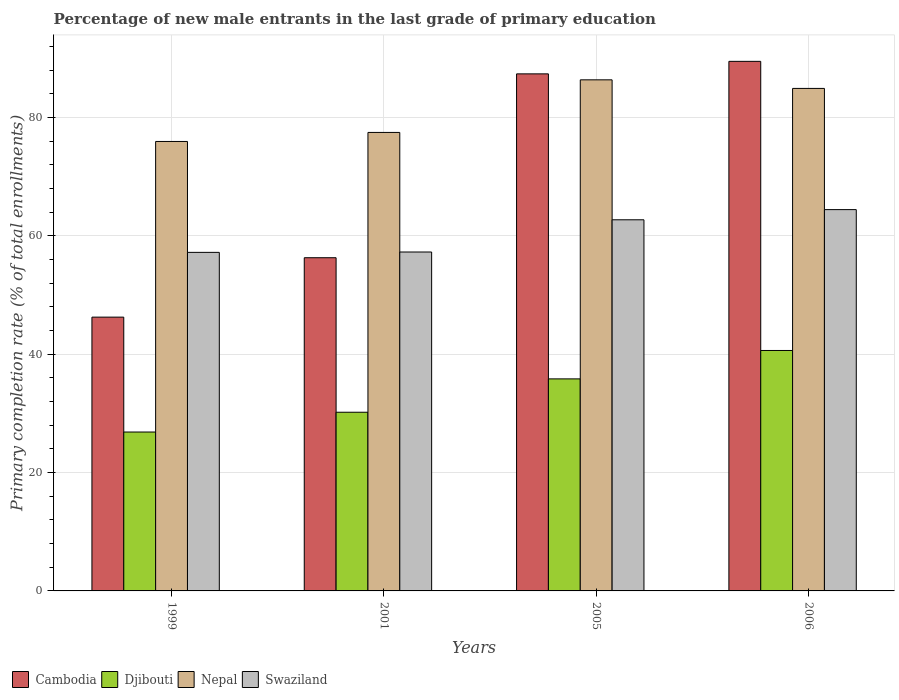Are the number of bars per tick equal to the number of legend labels?
Your response must be concise. Yes. Are the number of bars on each tick of the X-axis equal?
Your answer should be very brief. Yes. How many bars are there on the 3rd tick from the left?
Keep it short and to the point. 4. How many bars are there on the 4th tick from the right?
Keep it short and to the point. 4. What is the percentage of new male entrants in Nepal in 2005?
Keep it short and to the point. 86.36. Across all years, what is the maximum percentage of new male entrants in Cambodia?
Give a very brief answer. 89.49. Across all years, what is the minimum percentage of new male entrants in Swaziland?
Provide a succinct answer. 57.21. What is the total percentage of new male entrants in Swaziland in the graph?
Give a very brief answer. 241.63. What is the difference between the percentage of new male entrants in Swaziland in 2001 and that in 2006?
Your answer should be very brief. -7.16. What is the difference between the percentage of new male entrants in Swaziland in 2005 and the percentage of new male entrants in Nepal in 2006?
Your response must be concise. -22.2. What is the average percentage of new male entrants in Nepal per year?
Your answer should be compact. 81.18. In the year 2006, what is the difference between the percentage of new male entrants in Swaziland and percentage of new male entrants in Cambodia?
Your answer should be very brief. -25.05. What is the ratio of the percentage of new male entrants in Nepal in 2001 to that in 2005?
Your answer should be compact. 0.9. Is the percentage of new male entrants in Swaziland in 2001 less than that in 2005?
Provide a succinct answer. Yes. Is the difference between the percentage of new male entrants in Swaziland in 1999 and 2001 greater than the difference between the percentage of new male entrants in Cambodia in 1999 and 2001?
Give a very brief answer. Yes. What is the difference between the highest and the second highest percentage of new male entrants in Cambodia?
Ensure brevity in your answer.  2.12. What is the difference between the highest and the lowest percentage of new male entrants in Djibouti?
Ensure brevity in your answer.  13.78. Is the sum of the percentage of new male entrants in Djibouti in 2001 and 2005 greater than the maximum percentage of new male entrants in Swaziland across all years?
Offer a very short reply. Yes. What does the 4th bar from the left in 2001 represents?
Provide a short and direct response. Swaziland. What does the 3rd bar from the right in 2006 represents?
Your answer should be very brief. Djibouti. How many bars are there?
Provide a succinct answer. 16. Does the graph contain any zero values?
Offer a terse response. No. What is the title of the graph?
Provide a short and direct response. Percentage of new male entrants in the last grade of primary education. Does "San Marino" appear as one of the legend labels in the graph?
Your response must be concise. No. What is the label or title of the Y-axis?
Offer a terse response. Primary completion rate (% of total enrollments). What is the Primary completion rate (% of total enrollments) in Cambodia in 1999?
Offer a very short reply. 46.26. What is the Primary completion rate (% of total enrollments) of Djibouti in 1999?
Make the answer very short. 26.85. What is the Primary completion rate (% of total enrollments) in Nepal in 1999?
Offer a terse response. 75.95. What is the Primary completion rate (% of total enrollments) in Swaziland in 1999?
Offer a terse response. 57.21. What is the Primary completion rate (% of total enrollments) of Cambodia in 2001?
Give a very brief answer. 56.3. What is the Primary completion rate (% of total enrollments) in Djibouti in 2001?
Your answer should be compact. 30.19. What is the Primary completion rate (% of total enrollments) of Nepal in 2001?
Provide a short and direct response. 77.48. What is the Primary completion rate (% of total enrollments) of Swaziland in 2001?
Provide a short and direct response. 57.27. What is the Primary completion rate (% of total enrollments) in Cambodia in 2005?
Give a very brief answer. 87.37. What is the Primary completion rate (% of total enrollments) of Djibouti in 2005?
Offer a terse response. 35.83. What is the Primary completion rate (% of total enrollments) in Nepal in 2005?
Offer a very short reply. 86.36. What is the Primary completion rate (% of total enrollments) in Swaziland in 2005?
Offer a very short reply. 62.72. What is the Primary completion rate (% of total enrollments) in Cambodia in 2006?
Your answer should be compact. 89.49. What is the Primary completion rate (% of total enrollments) in Djibouti in 2006?
Ensure brevity in your answer.  40.63. What is the Primary completion rate (% of total enrollments) in Nepal in 2006?
Your answer should be very brief. 84.91. What is the Primary completion rate (% of total enrollments) in Swaziland in 2006?
Your response must be concise. 64.43. Across all years, what is the maximum Primary completion rate (% of total enrollments) of Cambodia?
Make the answer very short. 89.49. Across all years, what is the maximum Primary completion rate (% of total enrollments) of Djibouti?
Your answer should be compact. 40.63. Across all years, what is the maximum Primary completion rate (% of total enrollments) of Nepal?
Provide a short and direct response. 86.36. Across all years, what is the maximum Primary completion rate (% of total enrollments) of Swaziland?
Make the answer very short. 64.43. Across all years, what is the minimum Primary completion rate (% of total enrollments) in Cambodia?
Give a very brief answer. 46.26. Across all years, what is the minimum Primary completion rate (% of total enrollments) in Djibouti?
Offer a very short reply. 26.85. Across all years, what is the minimum Primary completion rate (% of total enrollments) in Nepal?
Make the answer very short. 75.95. Across all years, what is the minimum Primary completion rate (% of total enrollments) in Swaziland?
Offer a very short reply. 57.21. What is the total Primary completion rate (% of total enrollments) of Cambodia in the graph?
Your answer should be compact. 279.43. What is the total Primary completion rate (% of total enrollments) of Djibouti in the graph?
Your answer should be compact. 133.5. What is the total Primary completion rate (% of total enrollments) in Nepal in the graph?
Make the answer very short. 324.71. What is the total Primary completion rate (% of total enrollments) in Swaziland in the graph?
Your answer should be very brief. 241.63. What is the difference between the Primary completion rate (% of total enrollments) in Cambodia in 1999 and that in 2001?
Make the answer very short. -10.04. What is the difference between the Primary completion rate (% of total enrollments) of Djibouti in 1999 and that in 2001?
Provide a succinct answer. -3.34. What is the difference between the Primary completion rate (% of total enrollments) of Nepal in 1999 and that in 2001?
Make the answer very short. -1.53. What is the difference between the Primary completion rate (% of total enrollments) of Swaziland in 1999 and that in 2001?
Keep it short and to the point. -0.06. What is the difference between the Primary completion rate (% of total enrollments) of Cambodia in 1999 and that in 2005?
Make the answer very short. -41.11. What is the difference between the Primary completion rate (% of total enrollments) of Djibouti in 1999 and that in 2005?
Make the answer very short. -8.98. What is the difference between the Primary completion rate (% of total enrollments) in Nepal in 1999 and that in 2005?
Give a very brief answer. -10.41. What is the difference between the Primary completion rate (% of total enrollments) of Swaziland in 1999 and that in 2005?
Offer a terse response. -5.5. What is the difference between the Primary completion rate (% of total enrollments) in Cambodia in 1999 and that in 2006?
Your response must be concise. -43.22. What is the difference between the Primary completion rate (% of total enrollments) in Djibouti in 1999 and that in 2006?
Ensure brevity in your answer.  -13.78. What is the difference between the Primary completion rate (% of total enrollments) in Nepal in 1999 and that in 2006?
Your response must be concise. -8.96. What is the difference between the Primary completion rate (% of total enrollments) in Swaziland in 1999 and that in 2006?
Your answer should be compact. -7.22. What is the difference between the Primary completion rate (% of total enrollments) of Cambodia in 2001 and that in 2005?
Offer a terse response. -31.07. What is the difference between the Primary completion rate (% of total enrollments) in Djibouti in 2001 and that in 2005?
Provide a short and direct response. -5.64. What is the difference between the Primary completion rate (% of total enrollments) of Nepal in 2001 and that in 2005?
Give a very brief answer. -8.89. What is the difference between the Primary completion rate (% of total enrollments) in Swaziland in 2001 and that in 2005?
Keep it short and to the point. -5.45. What is the difference between the Primary completion rate (% of total enrollments) of Cambodia in 2001 and that in 2006?
Your answer should be very brief. -33.18. What is the difference between the Primary completion rate (% of total enrollments) in Djibouti in 2001 and that in 2006?
Make the answer very short. -10.44. What is the difference between the Primary completion rate (% of total enrollments) in Nepal in 2001 and that in 2006?
Make the answer very short. -7.44. What is the difference between the Primary completion rate (% of total enrollments) of Swaziland in 2001 and that in 2006?
Offer a very short reply. -7.16. What is the difference between the Primary completion rate (% of total enrollments) of Cambodia in 2005 and that in 2006?
Provide a succinct answer. -2.12. What is the difference between the Primary completion rate (% of total enrollments) in Djibouti in 2005 and that in 2006?
Your response must be concise. -4.8. What is the difference between the Primary completion rate (% of total enrollments) of Nepal in 2005 and that in 2006?
Give a very brief answer. 1.45. What is the difference between the Primary completion rate (% of total enrollments) of Swaziland in 2005 and that in 2006?
Your answer should be very brief. -1.72. What is the difference between the Primary completion rate (% of total enrollments) in Cambodia in 1999 and the Primary completion rate (% of total enrollments) in Djibouti in 2001?
Give a very brief answer. 16.07. What is the difference between the Primary completion rate (% of total enrollments) in Cambodia in 1999 and the Primary completion rate (% of total enrollments) in Nepal in 2001?
Offer a very short reply. -31.21. What is the difference between the Primary completion rate (% of total enrollments) in Cambodia in 1999 and the Primary completion rate (% of total enrollments) in Swaziland in 2001?
Ensure brevity in your answer.  -11.01. What is the difference between the Primary completion rate (% of total enrollments) in Djibouti in 1999 and the Primary completion rate (% of total enrollments) in Nepal in 2001?
Offer a terse response. -50.63. What is the difference between the Primary completion rate (% of total enrollments) of Djibouti in 1999 and the Primary completion rate (% of total enrollments) of Swaziland in 2001?
Your response must be concise. -30.42. What is the difference between the Primary completion rate (% of total enrollments) in Nepal in 1999 and the Primary completion rate (% of total enrollments) in Swaziland in 2001?
Offer a very short reply. 18.68. What is the difference between the Primary completion rate (% of total enrollments) of Cambodia in 1999 and the Primary completion rate (% of total enrollments) of Djibouti in 2005?
Ensure brevity in your answer.  10.43. What is the difference between the Primary completion rate (% of total enrollments) in Cambodia in 1999 and the Primary completion rate (% of total enrollments) in Nepal in 2005?
Your response must be concise. -40.1. What is the difference between the Primary completion rate (% of total enrollments) of Cambodia in 1999 and the Primary completion rate (% of total enrollments) of Swaziland in 2005?
Provide a succinct answer. -16.45. What is the difference between the Primary completion rate (% of total enrollments) of Djibouti in 1999 and the Primary completion rate (% of total enrollments) of Nepal in 2005?
Your answer should be very brief. -59.51. What is the difference between the Primary completion rate (% of total enrollments) of Djibouti in 1999 and the Primary completion rate (% of total enrollments) of Swaziland in 2005?
Your answer should be very brief. -35.86. What is the difference between the Primary completion rate (% of total enrollments) in Nepal in 1999 and the Primary completion rate (% of total enrollments) in Swaziland in 2005?
Your answer should be very brief. 13.24. What is the difference between the Primary completion rate (% of total enrollments) in Cambodia in 1999 and the Primary completion rate (% of total enrollments) in Djibouti in 2006?
Ensure brevity in your answer.  5.63. What is the difference between the Primary completion rate (% of total enrollments) in Cambodia in 1999 and the Primary completion rate (% of total enrollments) in Nepal in 2006?
Give a very brief answer. -38.65. What is the difference between the Primary completion rate (% of total enrollments) of Cambodia in 1999 and the Primary completion rate (% of total enrollments) of Swaziland in 2006?
Provide a succinct answer. -18.17. What is the difference between the Primary completion rate (% of total enrollments) in Djibouti in 1999 and the Primary completion rate (% of total enrollments) in Nepal in 2006?
Your response must be concise. -58.06. What is the difference between the Primary completion rate (% of total enrollments) of Djibouti in 1999 and the Primary completion rate (% of total enrollments) of Swaziland in 2006?
Your answer should be compact. -37.58. What is the difference between the Primary completion rate (% of total enrollments) of Nepal in 1999 and the Primary completion rate (% of total enrollments) of Swaziland in 2006?
Your response must be concise. 11.52. What is the difference between the Primary completion rate (% of total enrollments) in Cambodia in 2001 and the Primary completion rate (% of total enrollments) in Djibouti in 2005?
Keep it short and to the point. 20.48. What is the difference between the Primary completion rate (% of total enrollments) in Cambodia in 2001 and the Primary completion rate (% of total enrollments) in Nepal in 2005?
Ensure brevity in your answer.  -30.06. What is the difference between the Primary completion rate (% of total enrollments) in Cambodia in 2001 and the Primary completion rate (% of total enrollments) in Swaziland in 2005?
Keep it short and to the point. -6.41. What is the difference between the Primary completion rate (% of total enrollments) in Djibouti in 2001 and the Primary completion rate (% of total enrollments) in Nepal in 2005?
Make the answer very short. -56.17. What is the difference between the Primary completion rate (% of total enrollments) of Djibouti in 2001 and the Primary completion rate (% of total enrollments) of Swaziland in 2005?
Ensure brevity in your answer.  -32.52. What is the difference between the Primary completion rate (% of total enrollments) in Nepal in 2001 and the Primary completion rate (% of total enrollments) in Swaziland in 2005?
Your response must be concise. 14.76. What is the difference between the Primary completion rate (% of total enrollments) of Cambodia in 2001 and the Primary completion rate (% of total enrollments) of Djibouti in 2006?
Keep it short and to the point. 15.67. What is the difference between the Primary completion rate (% of total enrollments) of Cambodia in 2001 and the Primary completion rate (% of total enrollments) of Nepal in 2006?
Offer a very short reply. -28.61. What is the difference between the Primary completion rate (% of total enrollments) of Cambodia in 2001 and the Primary completion rate (% of total enrollments) of Swaziland in 2006?
Provide a succinct answer. -8.13. What is the difference between the Primary completion rate (% of total enrollments) of Djibouti in 2001 and the Primary completion rate (% of total enrollments) of Nepal in 2006?
Ensure brevity in your answer.  -54.72. What is the difference between the Primary completion rate (% of total enrollments) of Djibouti in 2001 and the Primary completion rate (% of total enrollments) of Swaziland in 2006?
Keep it short and to the point. -34.24. What is the difference between the Primary completion rate (% of total enrollments) in Nepal in 2001 and the Primary completion rate (% of total enrollments) in Swaziland in 2006?
Ensure brevity in your answer.  13.04. What is the difference between the Primary completion rate (% of total enrollments) of Cambodia in 2005 and the Primary completion rate (% of total enrollments) of Djibouti in 2006?
Offer a very short reply. 46.74. What is the difference between the Primary completion rate (% of total enrollments) in Cambodia in 2005 and the Primary completion rate (% of total enrollments) in Nepal in 2006?
Give a very brief answer. 2.46. What is the difference between the Primary completion rate (% of total enrollments) in Cambodia in 2005 and the Primary completion rate (% of total enrollments) in Swaziland in 2006?
Provide a succinct answer. 22.94. What is the difference between the Primary completion rate (% of total enrollments) in Djibouti in 2005 and the Primary completion rate (% of total enrollments) in Nepal in 2006?
Give a very brief answer. -49.08. What is the difference between the Primary completion rate (% of total enrollments) in Djibouti in 2005 and the Primary completion rate (% of total enrollments) in Swaziland in 2006?
Provide a short and direct response. -28.6. What is the difference between the Primary completion rate (% of total enrollments) of Nepal in 2005 and the Primary completion rate (% of total enrollments) of Swaziland in 2006?
Your answer should be compact. 21.93. What is the average Primary completion rate (% of total enrollments) in Cambodia per year?
Keep it short and to the point. 69.86. What is the average Primary completion rate (% of total enrollments) in Djibouti per year?
Your answer should be compact. 33.38. What is the average Primary completion rate (% of total enrollments) of Nepal per year?
Keep it short and to the point. 81.18. What is the average Primary completion rate (% of total enrollments) of Swaziland per year?
Offer a terse response. 60.41. In the year 1999, what is the difference between the Primary completion rate (% of total enrollments) in Cambodia and Primary completion rate (% of total enrollments) in Djibouti?
Provide a short and direct response. 19.41. In the year 1999, what is the difference between the Primary completion rate (% of total enrollments) of Cambodia and Primary completion rate (% of total enrollments) of Nepal?
Your response must be concise. -29.69. In the year 1999, what is the difference between the Primary completion rate (% of total enrollments) in Cambodia and Primary completion rate (% of total enrollments) in Swaziland?
Offer a very short reply. -10.95. In the year 1999, what is the difference between the Primary completion rate (% of total enrollments) in Djibouti and Primary completion rate (% of total enrollments) in Nepal?
Provide a succinct answer. -49.1. In the year 1999, what is the difference between the Primary completion rate (% of total enrollments) in Djibouti and Primary completion rate (% of total enrollments) in Swaziland?
Offer a terse response. -30.36. In the year 1999, what is the difference between the Primary completion rate (% of total enrollments) of Nepal and Primary completion rate (% of total enrollments) of Swaziland?
Give a very brief answer. 18.74. In the year 2001, what is the difference between the Primary completion rate (% of total enrollments) of Cambodia and Primary completion rate (% of total enrollments) of Djibouti?
Offer a terse response. 26.11. In the year 2001, what is the difference between the Primary completion rate (% of total enrollments) of Cambodia and Primary completion rate (% of total enrollments) of Nepal?
Offer a terse response. -21.17. In the year 2001, what is the difference between the Primary completion rate (% of total enrollments) in Cambodia and Primary completion rate (% of total enrollments) in Swaziland?
Your answer should be very brief. -0.97. In the year 2001, what is the difference between the Primary completion rate (% of total enrollments) in Djibouti and Primary completion rate (% of total enrollments) in Nepal?
Offer a terse response. -47.28. In the year 2001, what is the difference between the Primary completion rate (% of total enrollments) in Djibouti and Primary completion rate (% of total enrollments) in Swaziland?
Offer a terse response. -27.08. In the year 2001, what is the difference between the Primary completion rate (% of total enrollments) in Nepal and Primary completion rate (% of total enrollments) in Swaziland?
Provide a succinct answer. 20.21. In the year 2005, what is the difference between the Primary completion rate (% of total enrollments) in Cambodia and Primary completion rate (% of total enrollments) in Djibouti?
Your answer should be compact. 51.54. In the year 2005, what is the difference between the Primary completion rate (% of total enrollments) of Cambodia and Primary completion rate (% of total enrollments) of Swaziland?
Offer a very short reply. 24.66. In the year 2005, what is the difference between the Primary completion rate (% of total enrollments) of Djibouti and Primary completion rate (% of total enrollments) of Nepal?
Ensure brevity in your answer.  -50.53. In the year 2005, what is the difference between the Primary completion rate (% of total enrollments) of Djibouti and Primary completion rate (% of total enrollments) of Swaziland?
Your answer should be compact. -26.89. In the year 2005, what is the difference between the Primary completion rate (% of total enrollments) of Nepal and Primary completion rate (% of total enrollments) of Swaziland?
Your response must be concise. 23.65. In the year 2006, what is the difference between the Primary completion rate (% of total enrollments) in Cambodia and Primary completion rate (% of total enrollments) in Djibouti?
Ensure brevity in your answer.  48.86. In the year 2006, what is the difference between the Primary completion rate (% of total enrollments) of Cambodia and Primary completion rate (% of total enrollments) of Nepal?
Your answer should be compact. 4.57. In the year 2006, what is the difference between the Primary completion rate (% of total enrollments) of Cambodia and Primary completion rate (% of total enrollments) of Swaziland?
Your answer should be compact. 25.05. In the year 2006, what is the difference between the Primary completion rate (% of total enrollments) of Djibouti and Primary completion rate (% of total enrollments) of Nepal?
Offer a very short reply. -44.28. In the year 2006, what is the difference between the Primary completion rate (% of total enrollments) in Djibouti and Primary completion rate (% of total enrollments) in Swaziland?
Keep it short and to the point. -23.8. In the year 2006, what is the difference between the Primary completion rate (% of total enrollments) of Nepal and Primary completion rate (% of total enrollments) of Swaziland?
Your answer should be compact. 20.48. What is the ratio of the Primary completion rate (% of total enrollments) of Cambodia in 1999 to that in 2001?
Offer a terse response. 0.82. What is the ratio of the Primary completion rate (% of total enrollments) in Djibouti in 1999 to that in 2001?
Provide a succinct answer. 0.89. What is the ratio of the Primary completion rate (% of total enrollments) of Nepal in 1999 to that in 2001?
Ensure brevity in your answer.  0.98. What is the ratio of the Primary completion rate (% of total enrollments) in Swaziland in 1999 to that in 2001?
Ensure brevity in your answer.  1. What is the ratio of the Primary completion rate (% of total enrollments) in Cambodia in 1999 to that in 2005?
Provide a succinct answer. 0.53. What is the ratio of the Primary completion rate (% of total enrollments) of Djibouti in 1999 to that in 2005?
Provide a succinct answer. 0.75. What is the ratio of the Primary completion rate (% of total enrollments) in Nepal in 1999 to that in 2005?
Make the answer very short. 0.88. What is the ratio of the Primary completion rate (% of total enrollments) in Swaziland in 1999 to that in 2005?
Your answer should be compact. 0.91. What is the ratio of the Primary completion rate (% of total enrollments) of Cambodia in 1999 to that in 2006?
Make the answer very short. 0.52. What is the ratio of the Primary completion rate (% of total enrollments) of Djibouti in 1999 to that in 2006?
Your response must be concise. 0.66. What is the ratio of the Primary completion rate (% of total enrollments) in Nepal in 1999 to that in 2006?
Your answer should be very brief. 0.89. What is the ratio of the Primary completion rate (% of total enrollments) in Swaziland in 1999 to that in 2006?
Your response must be concise. 0.89. What is the ratio of the Primary completion rate (% of total enrollments) in Cambodia in 2001 to that in 2005?
Provide a short and direct response. 0.64. What is the ratio of the Primary completion rate (% of total enrollments) of Djibouti in 2001 to that in 2005?
Keep it short and to the point. 0.84. What is the ratio of the Primary completion rate (% of total enrollments) of Nepal in 2001 to that in 2005?
Make the answer very short. 0.9. What is the ratio of the Primary completion rate (% of total enrollments) in Swaziland in 2001 to that in 2005?
Give a very brief answer. 0.91. What is the ratio of the Primary completion rate (% of total enrollments) of Cambodia in 2001 to that in 2006?
Your response must be concise. 0.63. What is the ratio of the Primary completion rate (% of total enrollments) in Djibouti in 2001 to that in 2006?
Offer a very short reply. 0.74. What is the ratio of the Primary completion rate (% of total enrollments) of Nepal in 2001 to that in 2006?
Provide a short and direct response. 0.91. What is the ratio of the Primary completion rate (% of total enrollments) of Swaziland in 2001 to that in 2006?
Offer a terse response. 0.89. What is the ratio of the Primary completion rate (% of total enrollments) of Cambodia in 2005 to that in 2006?
Your answer should be compact. 0.98. What is the ratio of the Primary completion rate (% of total enrollments) of Djibouti in 2005 to that in 2006?
Give a very brief answer. 0.88. What is the ratio of the Primary completion rate (% of total enrollments) of Nepal in 2005 to that in 2006?
Provide a succinct answer. 1.02. What is the ratio of the Primary completion rate (% of total enrollments) of Swaziland in 2005 to that in 2006?
Your response must be concise. 0.97. What is the difference between the highest and the second highest Primary completion rate (% of total enrollments) of Cambodia?
Offer a very short reply. 2.12. What is the difference between the highest and the second highest Primary completion rate (% of total enrollments) of Djibouti?
Make the answer very short. 4.8. What is the difference between the highest and the second highest Primary completion rate (% of total enrollments) in Nepal?
Offer a terse response. 1.45. What is the difference between the highest and the second highest Primary completion rate (% of total enrollments) of Swaziland?
Your answer should be very brief. 1.72. What is the difference between the highest and the lowest Primary completion rate (% of total enrollments) of Cambodia?
Offer a terse response. 43.22. What is the difference between the highest and the lowest Primary completion rate (% of total enrollments) in Djibouti?
Offer a terse response. 13.78. What is the difference between the highest and the lowest Primary completion rate (% of total enrollments) in Nepal?
Your response must be concise. 10.41. What is the difference between the highest and the lowest Primary completion rate (% of total enrollments) in Swaziland?
Provide a short and direct response. 7.22. 